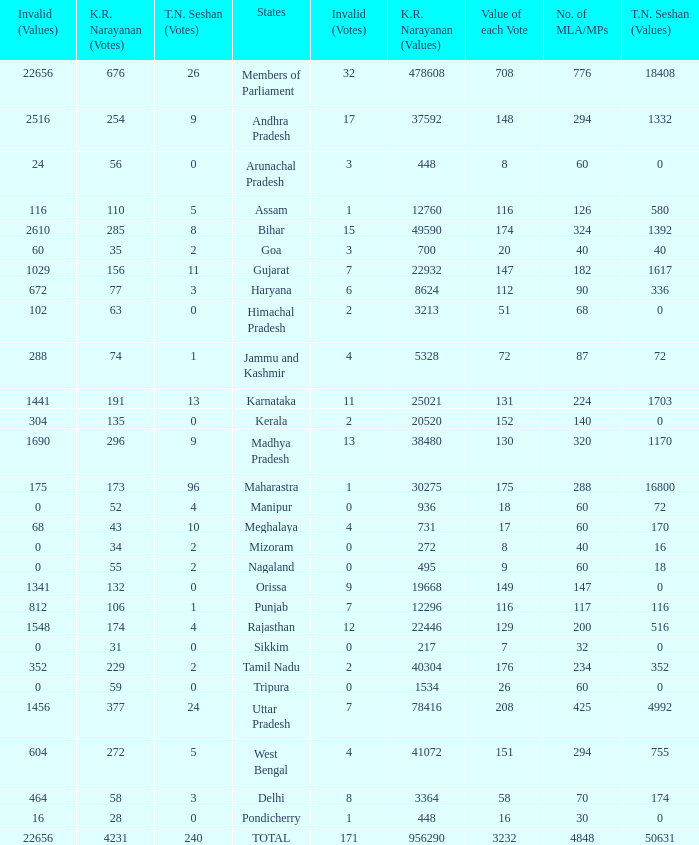Name the number of tn seshan values for kr values is 478608 1.0. 